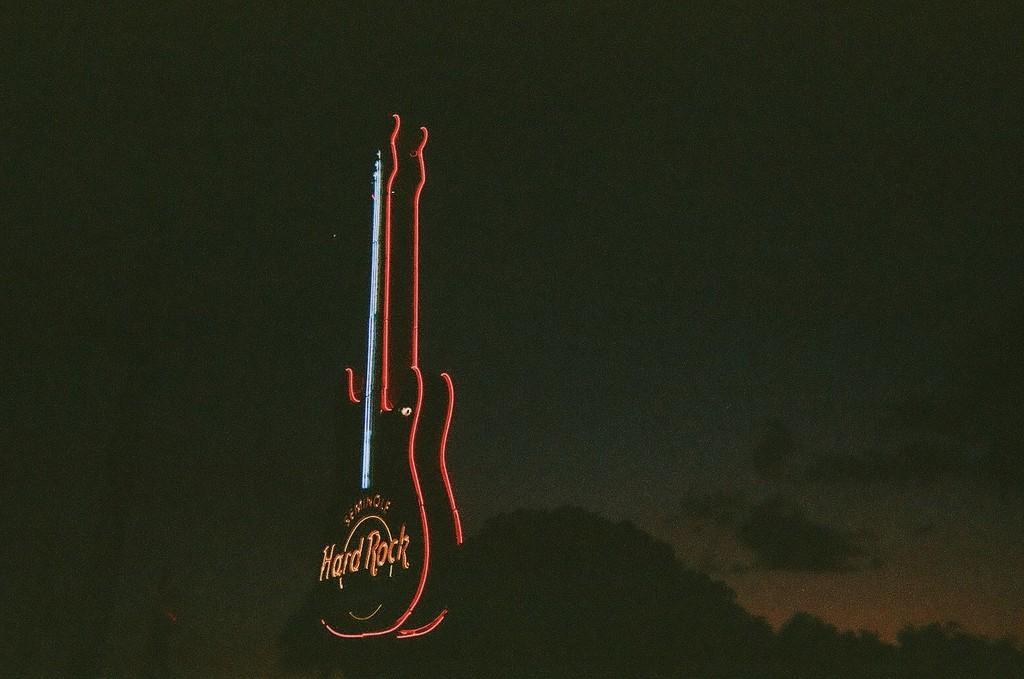Could you give a brief overview of what you see in this image? In the image there is neon light in shape of guitar and in the back it seems to be a tree and above its sky. 